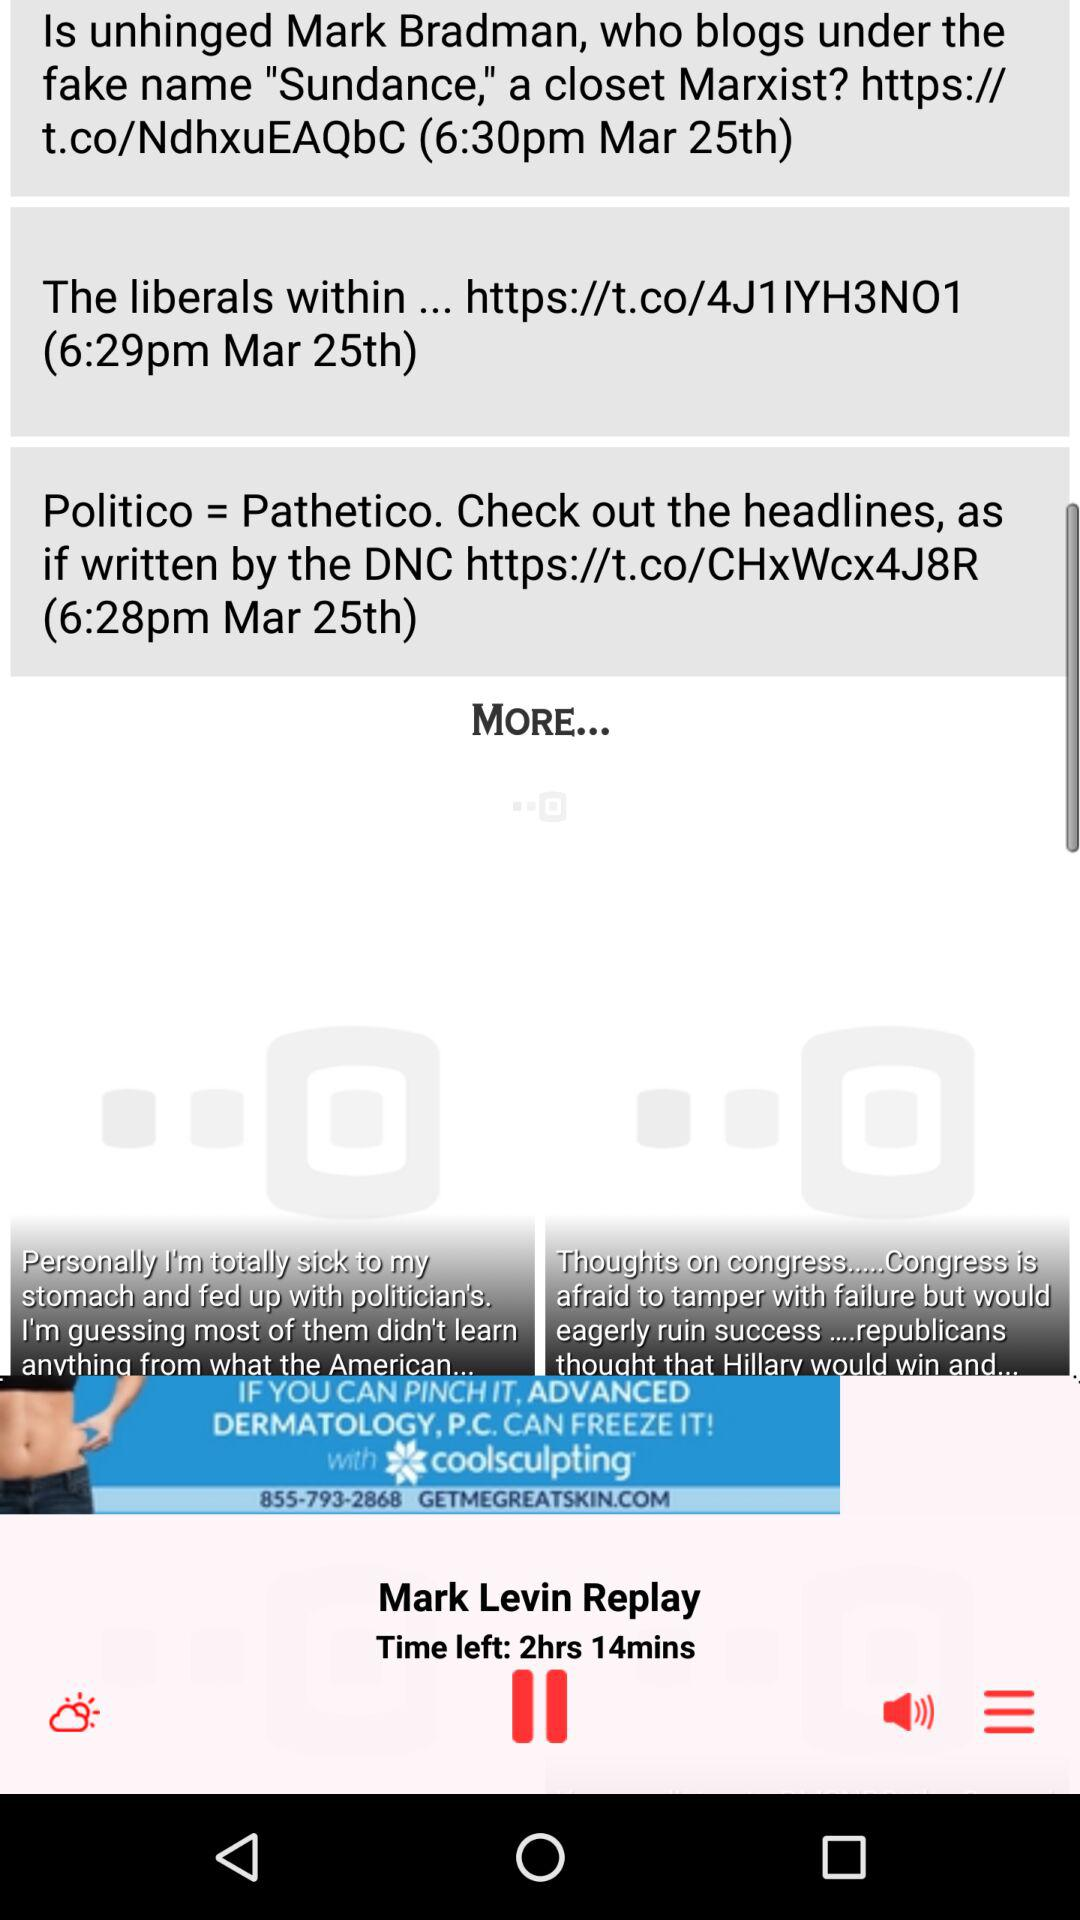How much time is left? The time left is 2 hours and 14 minutes. 